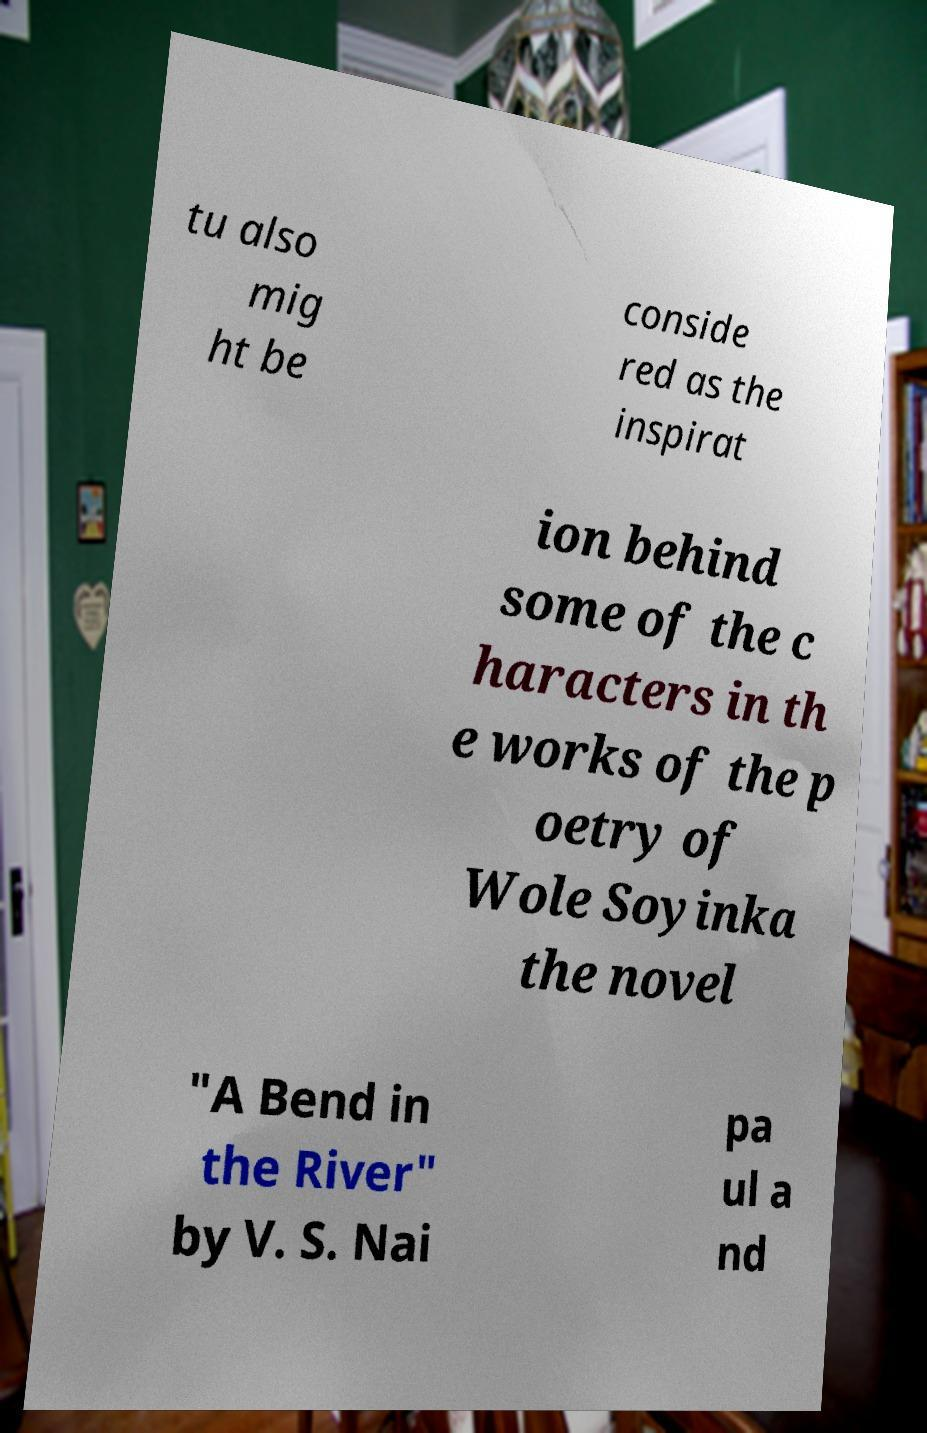Could you assist in decoding the text presented in this image and type it out clearly? tu also mig ht be conside red as the inspirat ion behind some of the c haracters in th e works of the p oetry of Wole Soyinka the novel "A Bend in the River" by V. S. Nai pa ul a nd 